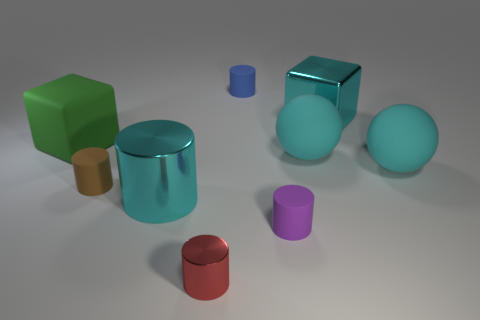What color is the large ball on the left side of the large cyan metal thing that is behind the large green matte thing?
Offer a terse response. Cyan. What material is the other thing that is the same shape as the big green thing?
Ensure brevity in your answer.  Metal. The large metal object in front of the cube to the left of the cyan metal thing on the left side of the large metal block is what color?
Your response must be concise. Cyan. What number of things are big cyan cylinders or gray matte cubes?
Your response must be concise. 1. What number of other metal things have the same shape as the green thing?
Provide a short and direct response. 1. Is the material of the brown object the same as the tiny thing that is in front of the purple matte object?
Offer a terse response. No. What is the size of the cyan block that is the same material as the tiny red thing?
Make the answer very short. Large. There is a block that is to the right of the blue object; what is its size?
Offer a terse response. Large. How many red metal cylinders are the same size as the green cube?
Offer a terse response. 0. There is a cylinder that is the same color as the shiny cube; what size is it?
Provide a short and direct response. Large. 